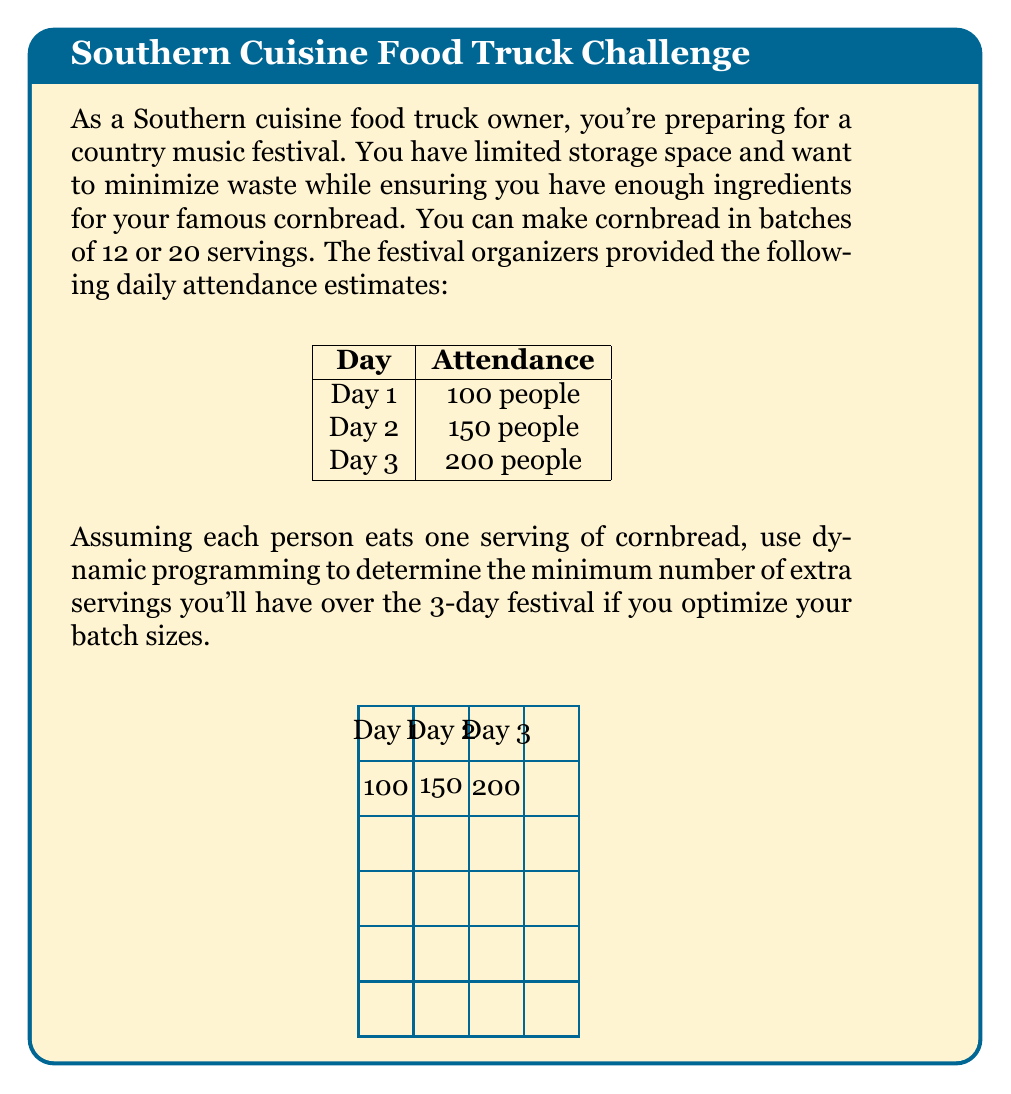Give your solution to this math problem. Let's solve this problem using dynamic programming:

1) Define the subproblem:
   Let $dp[i][j]$ be the minimum number of extra servings after day $i$, with $j$ leftover servings from the previous day.

2) Base case:
   $dp[0][j] = j$ for all $j$, as any leftover servings before day 1 are extras.

3) Recurrence relation:
   For each day $i$ and leftover $j$:
   $$dp[i][j] = \min_{k \in \{0,1,2,...\}} \{dp[i-1][(j + 12k - \text{demand}_i) \bmod 20] + (j + 12k - \text{demand}_i) \div 20\}$$
   where $k$ is the number of 12-serving batches made, and we consider making 0 to as many batches as needed.

4) Calculate:
   Day 1: demand = 100
   $dp[1][j] = \min(dp[0][j+8], dp[0][j], dp[0][j+12], dp[0][j+4], ...)$
   Optimal: Make 9 batches of 12 (108 servings), $dp[1][8] = 8$

   Day 2: demand = 150
   $dp[2][j] = \min(dp[1][j+10], dp[1][j+2], dp[1][j+14], ...)$
   Optimal: Make 12 batches of 12 (144 servings) + 8 from previous day, $dp[2][2] = 2$

   Day 3: demand = 200
   $dp[3][j] = \min(dp[2][j+4], dp[2][j+16], dp[2][j+8], ...)$
   Optimal: Make 17 batches of 12 (204 servings) + 2 from previous day, $dp[3][6] = 6$

5) The final answer is $dp[3][6] = 6$, meaning we end up with 6 extra servings over the 3-day festival.
Answer: 6 